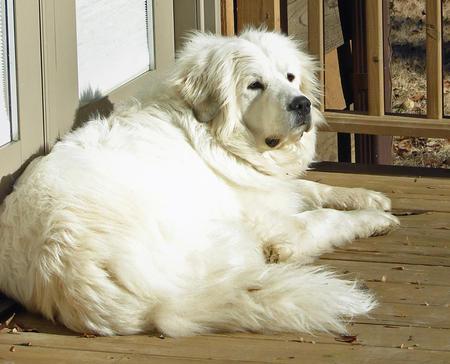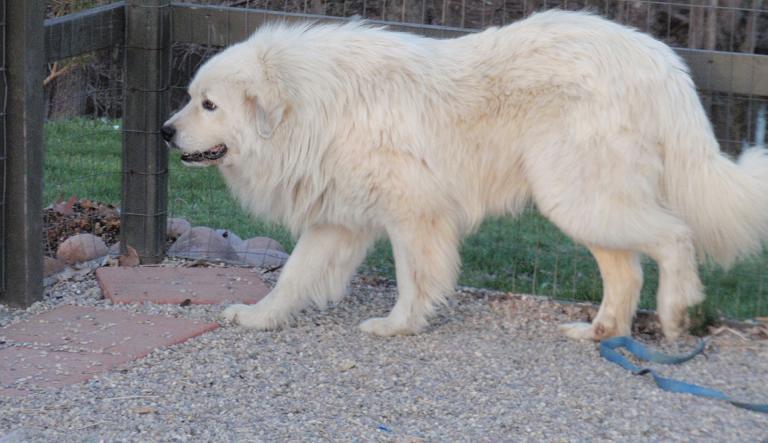The first image is the image on the left, the second image is the image on the right. Assess this claim about the two images: "There is a large dog with a child in one image, and a similar dog with it's mouth open in the other.". Correct or not? Answer yes or no. No. The first image is the image on the left, the second image is the image on the right. For the images displayed, is the sentence "One dog is laying in the dirt." factually correct? Answer yes or no. No. 